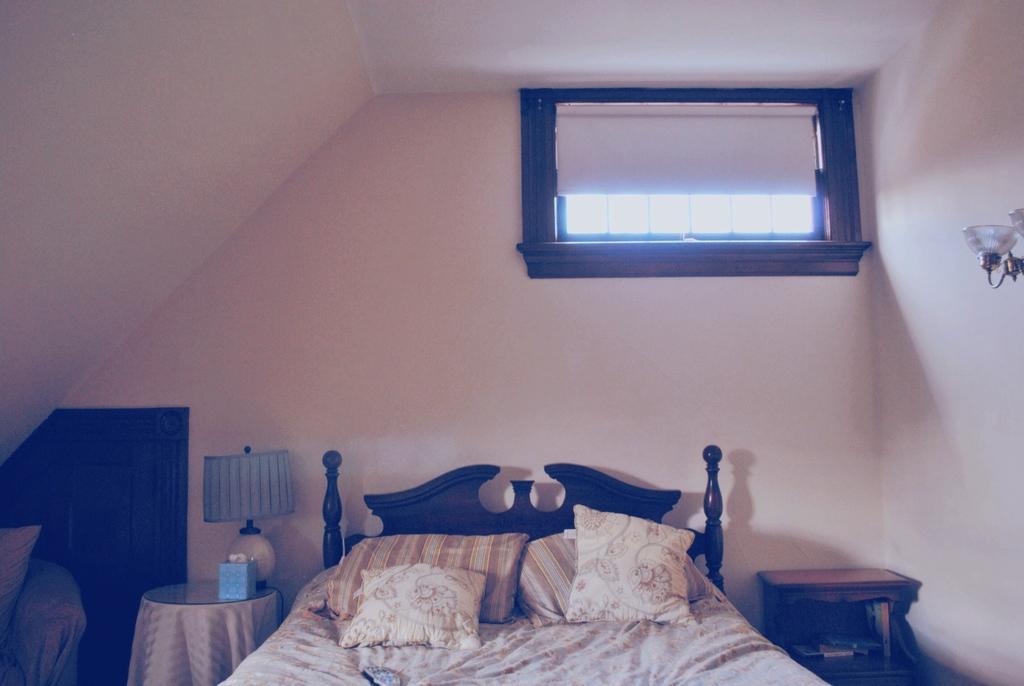Can you describe this image briefly? This is a window , wall and light. here we can see a bed with bed sheet and pillows. Near to it we can see a desk and a table and on the table we can see a bed lamp. 